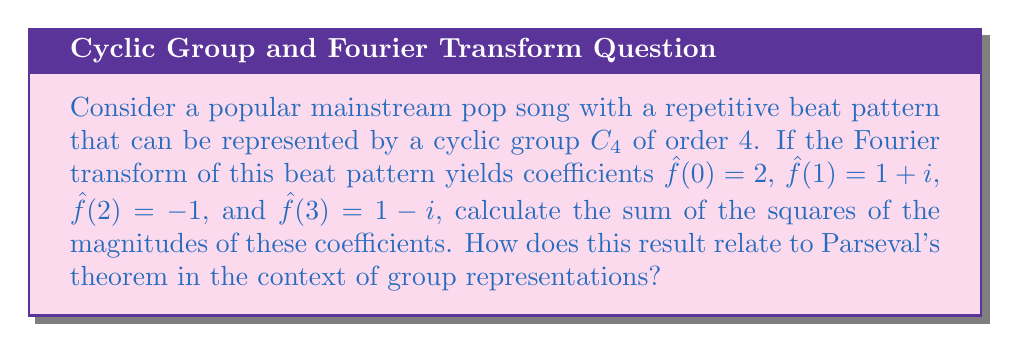Can you answer this question? Let's approach this step-by-step:

1) First, we need to calculate the magnitude of each Fourier coefficient:

   For $\hat{f}(0)$: $|\hat{f}(0)|^2 = 2^2 = 4$
   For $\hat{f}(1)$: $|\hat{f}(1)|^2 = (1+i)(1-i) = 1^2 + 1^2 = 2$
   For $\hat{f}(2)$: $|\hat{f}(2)|^2 = (-1)^2 = 1$
   For $\hat{f}(3)$: $|\hat{f}(3)|^2 = (1-i)(1+i) = 1^2 + 1^2 = 2$

2) Now, we sum the squares of these magnitudes:

   $\sum_{k=0}^3 |\hat{f}(k)|^2 = 4 + 2 + 1 + 2 = 9$

3) In the context of group representations and Parseval's theorem, this sum has a special meaning. Parseval's theorem for finite groups states that:

   $$\sum_{g \in G} |f(g)|^2 = \frac{1}{|G|} \sum_{\chi} |\hat{f}(\chi)|^2$$

   where $G$ is the group, $f$ is a function on the group, $\hat{f}$ are its Fourier coefficients, and $\chi$ runs over all irreducible representations of $G$.

4) In our case, $G = C_4$, so $|G| = 4$. The left side of Parseval's equation would be:

   $$4 \cdot \frac{1}{4} \sum_{k=0}^3 |\hat{f}(k)|^2 = 9$$

5) This means that the sum of the squares of the function values in the time domain is equal to 9, which is preserved in the frequency domain (represented by the Fourier coefficients).

6) This preservation of energy between the time and frequency domains is a fundamental property of the Fourier transform, which is crucial in analyzing the spectral content of music while maintaining its overall intensity.
Answer: 9; It demonstrates the energy preservation between time and frequency domains in the song's beat pattern. 